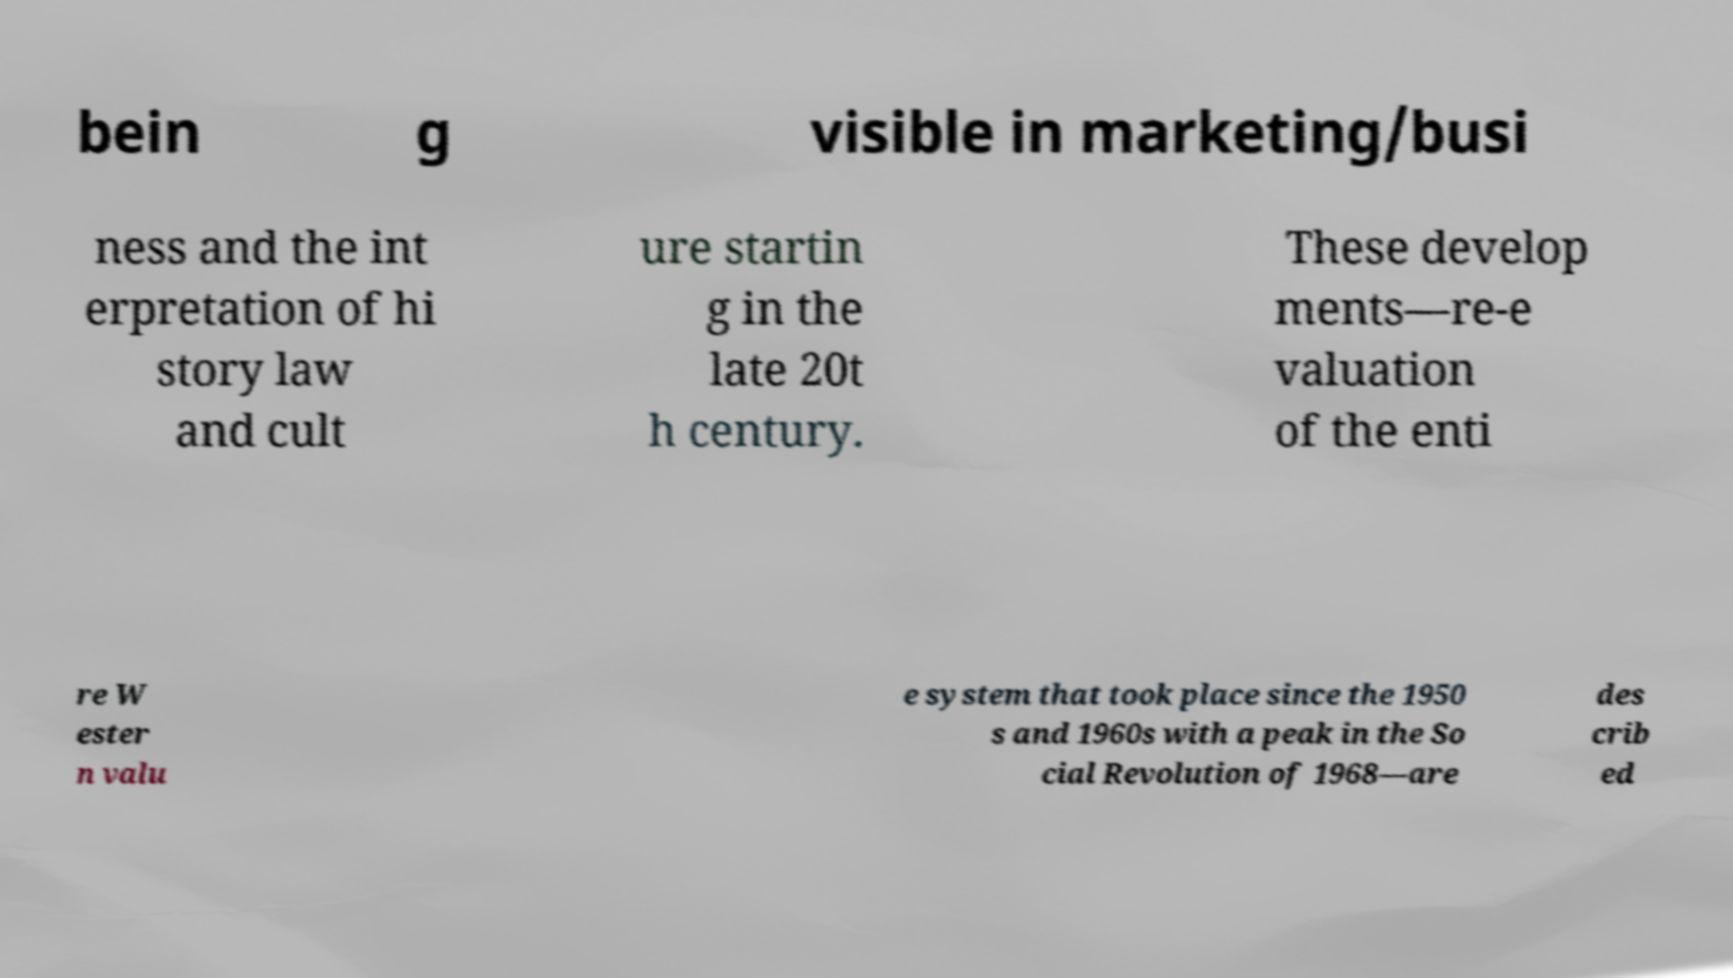Please read and relay the text visible in this image. What does it say? bein g visible in marketing/busi ness and the int erpretation of hi story law and cult ure startin g in the late 20t h century. These develop ments—re-e valuation of the enti re W ester n valu e system that took place since the 1950 s and 1960s with a peak in the So cial Revolution of 1968—are des crib ed 